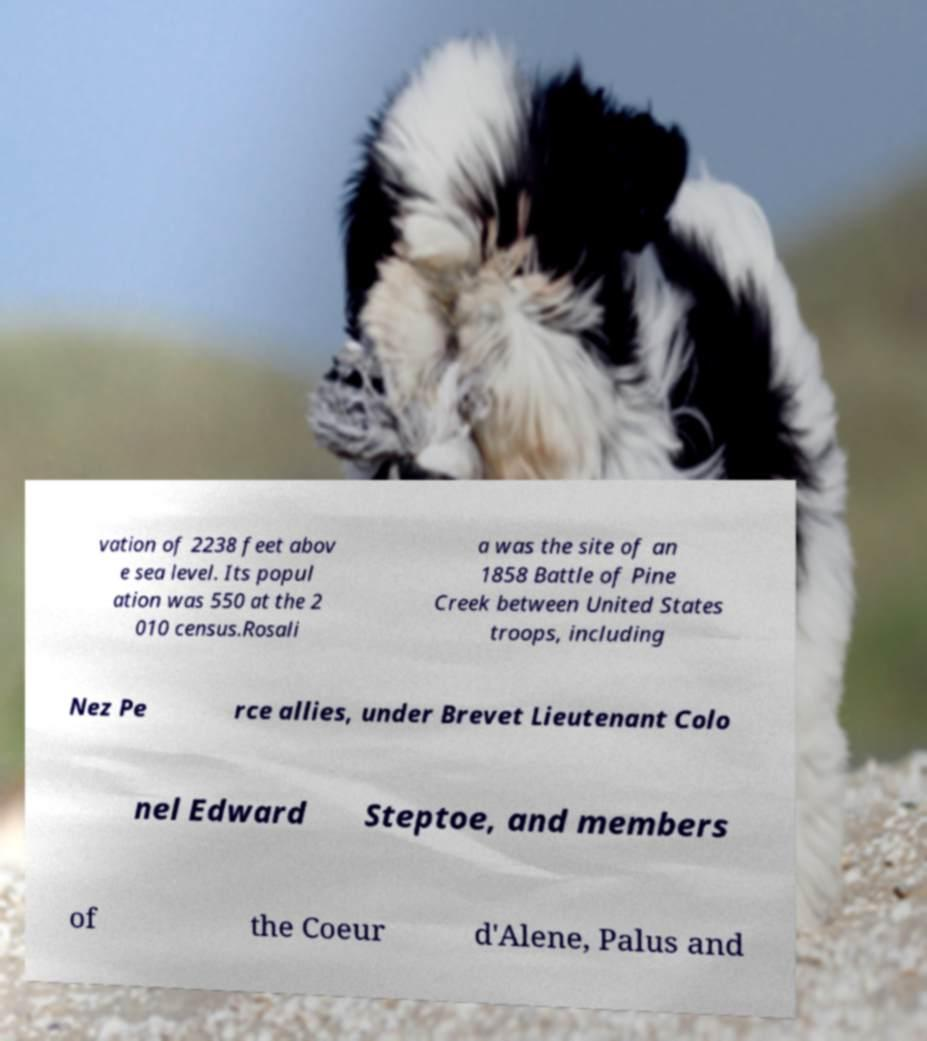Please read and relay the text visible in this image. What does it say? vation of 2238 feet abov e sea level. Its popul ation was 550 at the 2 010 census.Rosali a was the site of an 1858 Battle of Pine Creek between United States troops, including Nez Pe rce allies, under Brevet Lieutenant Colo nel Edward Steptoe, and members of the Coeur d'Alene, Palus and 